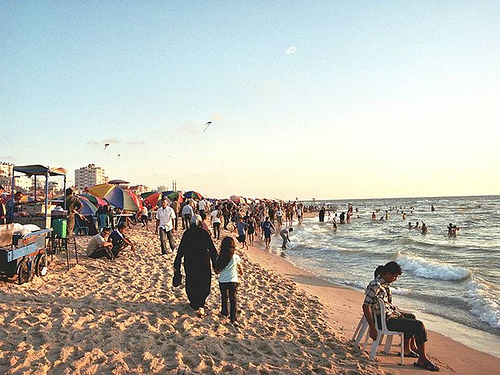Where is the chair? The chair is positioned on the sandy beach, close to the water's edge on the right side of the image, set slightly apart from the bustling crowd. 